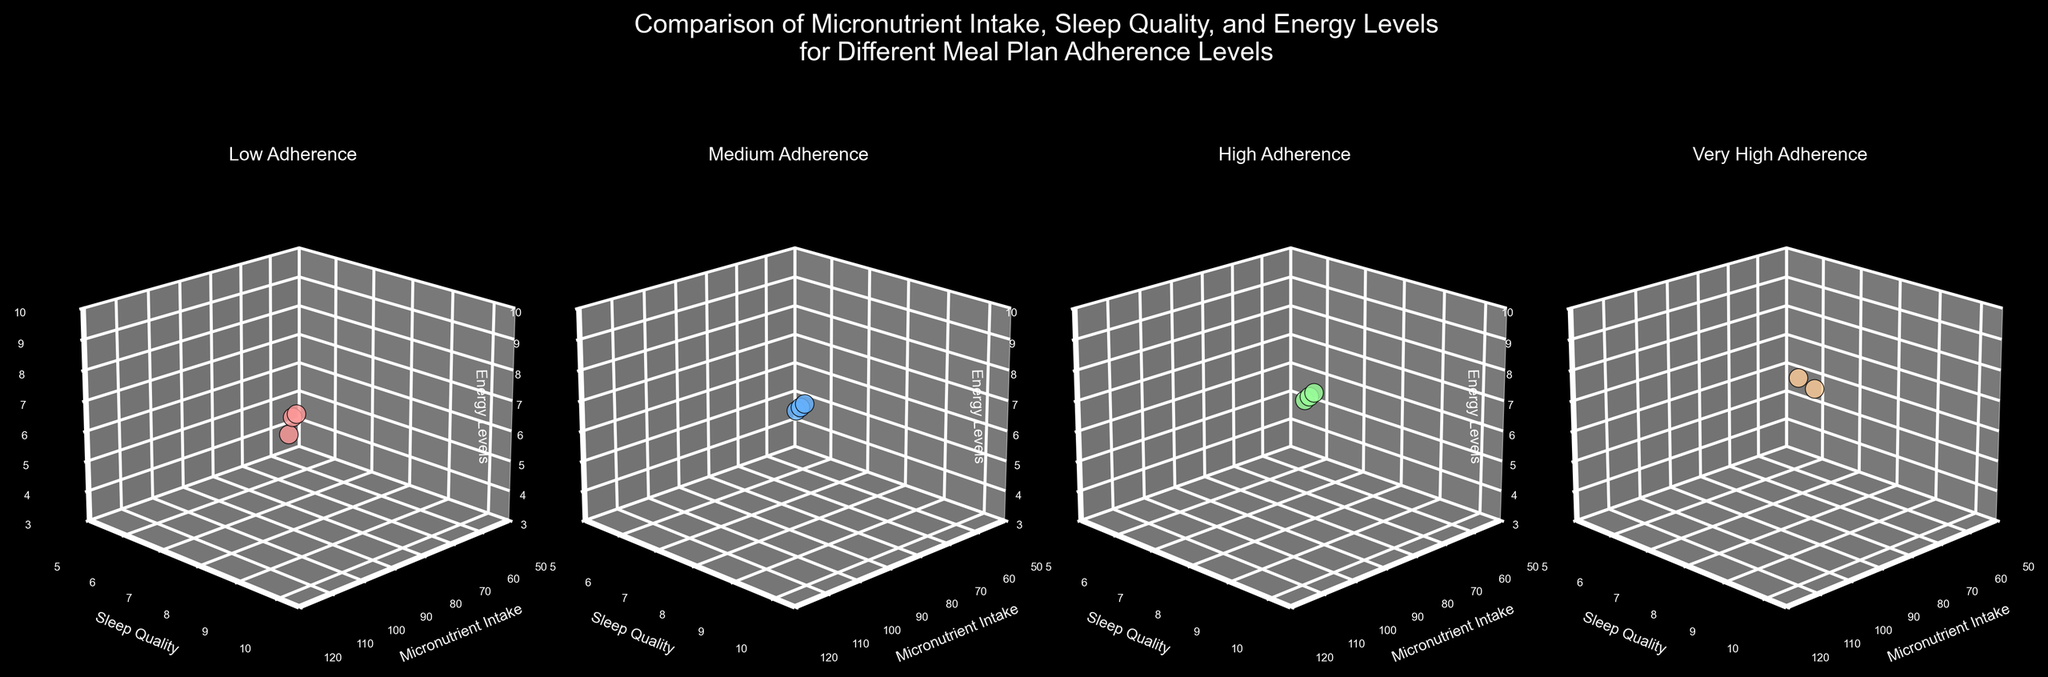What are the meal plan adherence levels shown in the plots? The titles of the subplots indicate four levels of meal plan adherence: "Low," "Medium," "High," and "Very High."
Answer: "Low," "Medium," "High," "Very High." How many data points are plotted in the "Medium" adherence subplot? By counting the number of dots in the "Medium" adherence subplot, we see there are three data points.
Answer: Three What is the general trend of micronutrient intake across different meal plan adherence levels? Each subsequent subplot (from "Low" to "Very High") shows higher values of micronutrient intake on the x-axis.
Answer: Increasing Which adherence level has the highest average sleep quality? By observing the average positioning of points on the y-axis across subplots, "Very High" adherence seems to have the highest average sleep quality.
Answer: Very High Which adherence level has the largest spread in energy levels? The "Very High" adherence level has points clustered at the top of the z-axis, indicating a narrow range, while "Low" adherence shows a wider spread on the z-axis.
Answer: Low Is there any adherence level where sleep quality and energy levels appear to remain almost constant? In the "Very High" adherence subplot, both sleep quality and energy levels are almost constant, as they fall within a tight range (10 for sleep quality and around 9 to 9.5 for energy levels).
Answer: Very High What is the maximum value of micronutrient intake observed in the plots? The highest value on the x-axis across all subplots is 110, observed in the "Very High" adherence subplot.
Answer: 110 Which adherence level shows a significant increase in sleep quality compared to the previous level? Comparing the "High" and "Very High" adherence subplots, there is a steep increase in the y-axis values for sleep quality from 9 to 10.
Answer: Very High Do any subplots show an overlap or intersection of data points along different axes? The "Low" adherence level subplot has points that overlap in terms of sleep quality and energy levels on the y-axis and z-axis.
Answer: Low What is the lowest value of energy levels recorded across all adherence levels? Observing the z-axis across subplots, the lowest energy level recorded is 4, seen in the "Low" adherence subplot.
Answer: 4 